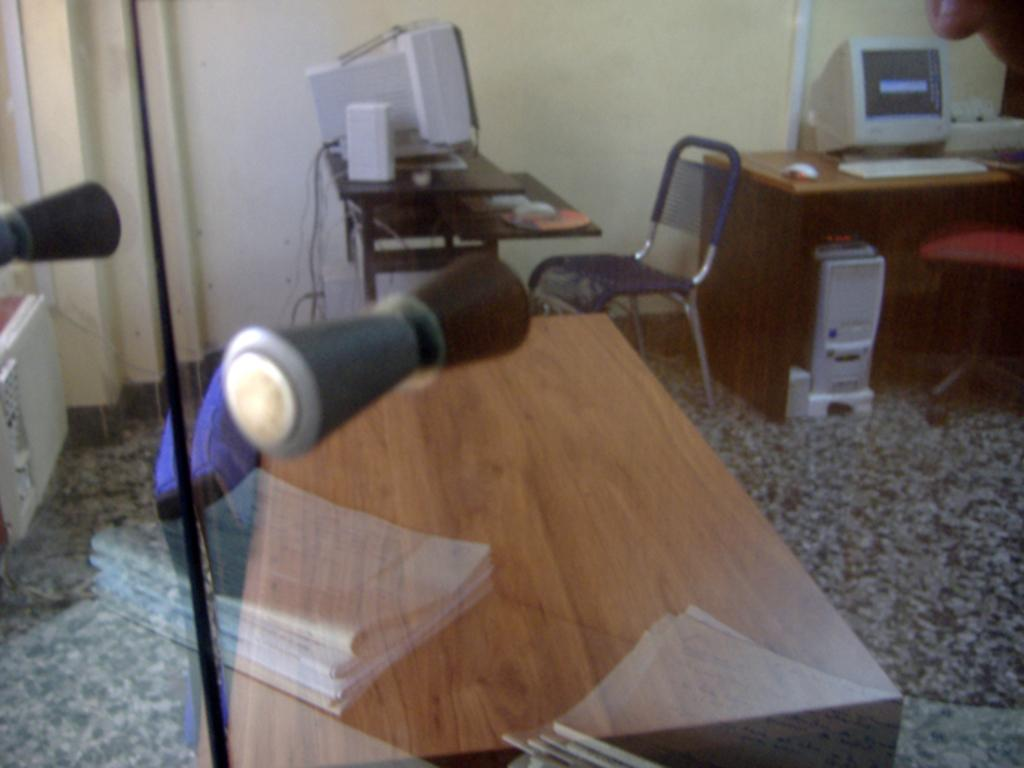What type of furniture is present in the image? There are tables and chairs in the image. What electronic devices can be seen in the image? There are computers in the image. How many matches are on the table in the image? There are no matches present in the image. What type of parcel is being delivered in the image? There is no parcel being delivered in the image. 